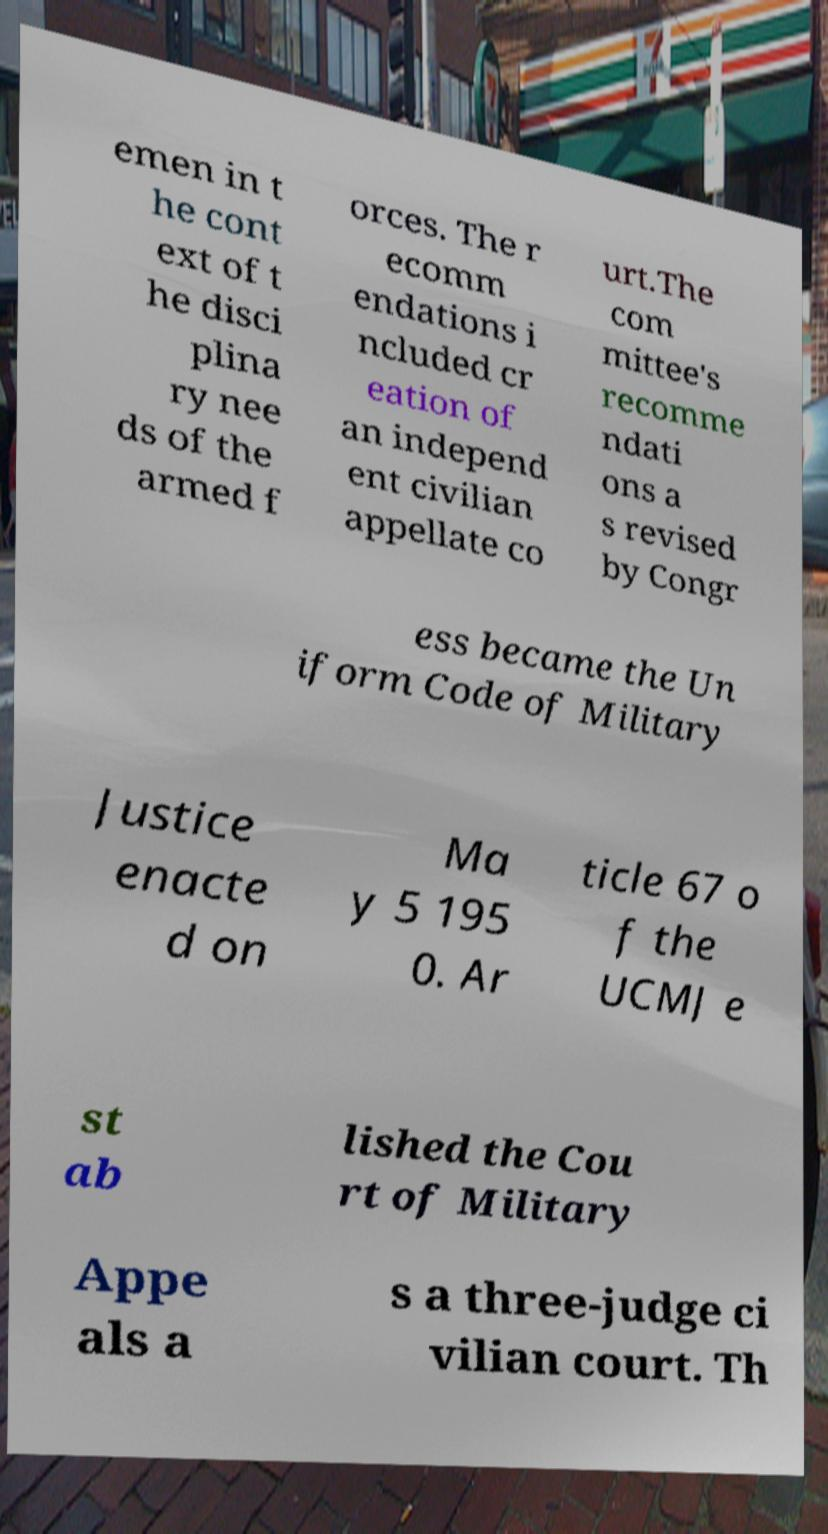Please read and relay the text visible in this image. What does it say? emen in t he cont ext of t he disci plina ry nee ds of the armed f orces. The r ecomm endations i ncluded cr eation of an independ ent civilian appellate co urt.The com mittee's recomme ndati ons a s revised by Congr ess became the Un iform Code of Military Justice enacte d on Ma y 5 195 0. Ar ticle 67 o f the UCMJ e st ab lished the Cou rt of Military Appe als a s a three-judge ci vilian court. Th 